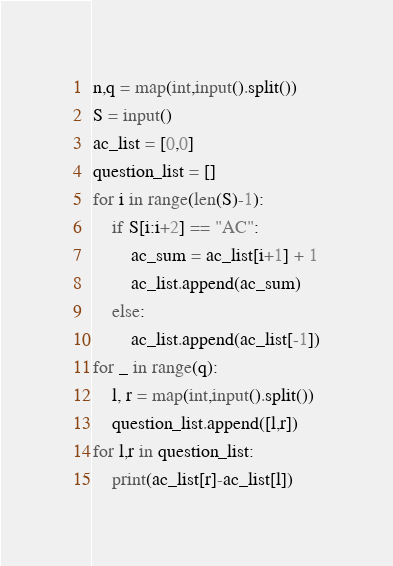Convert code to text. <code><loc_0><loc_0><loc_500><loc_500><_Python_>n,q = map(int,input().split())
S = input()
ac_list = [0,0]
question_list = []
for i in range(len(S)-1):
    if S[i:i+2] == "AC":
        ac_sum = ac_list[i+1] + 1
        ac_list.append(ac_sum)
    else:
        ac_list.append(ac_list[-1])
for _ in range(q):
    l, r = map(int,input().split())
    question_list.append([l,r])
for l,r in question_list:
    print(ac_list[r]-ac_list[l])</code> 